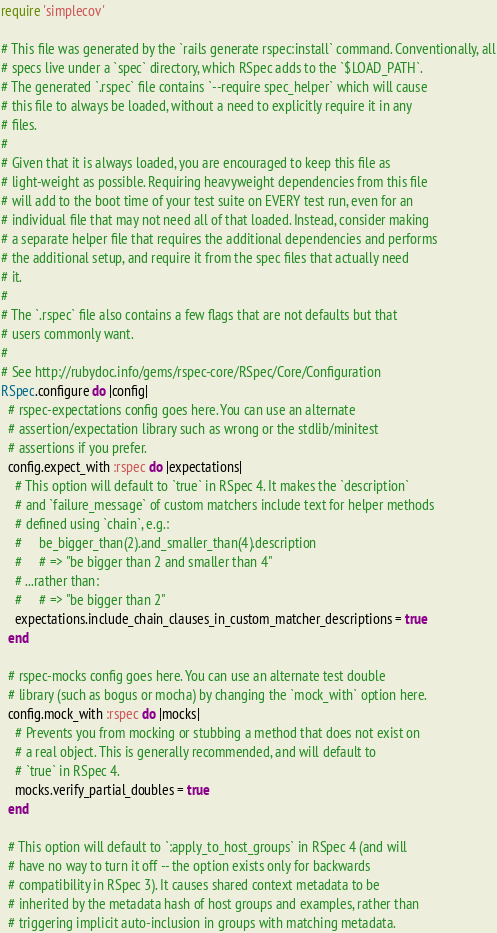<code> <loc_0><loc_0><loc_500><loc_500><_Ruby_>require 'simplecov'

# This file was generated by the `rails generate rspec:install` command. Conventionally, all
# specs live under a `spec` directory, which RSpec adds to the `$LOAD_PATH`.
# The generated `.rspec` file contains `--require spec_helper` which will cause
# this file to always be loaded, without a need to explicitly require it in any
# files.
#
# Given that it is always loaded, you are encouraged to keep this file as
# light-weight as possible. Requiring heavyweight dependencies from this file
# will add to the boot time of your test suite on EVERY test run, even for an
# individual file that may not need all of that loaded. Instead, consider making
# a separate helper file that requires the additional dependencies and performs
# the additional setup, and require it from the spec files that actually need
# it.
#
# The `.rspec` file also contains a few flags that are not defaults but that
# users commonly want.
#
# See http://rubydoc.info/gems/rspec-core/RSpec/Core/Configuration
RSpec.configure do |config|
  # rspec-expectations config goes here. You can use an alternate
  # assertion/expectation library such as wrong or the stdlib/minitest
  # assertions if you prefer.
  config.expect_with :rspec do |expectations|
    # This option will default to `true` in RSpec 4. It makes the `description`
    # and `failure_message` of custom matchers include text for helper methods
    # defined using `chain`, e.g.:
    #     be_bigger_than(2).and_smaller_than(4).description
    #     # => "be bigger than 2 and smaller than 4"
    # ...rather than:
    #     # => "be bigger than 2"
    expectations.include_chain_clauses_in_custom_matcher_descriptions = true
  end

  # rspec-mocks config goes here. You can use an alternate test double
  # library (such as bogus or mocha) by changing the `mock_with` option here.
  config.mock_with :rspec do |mocks|
    # Prevents you from mocking or stubbing a method that does not exist on
    # a real object. This is generally recommended, and will default to
    # `true` in RSpec 4.
    mocks.verify_partial_doubles = true
  end

  # This option will default to `:apply_to_host_groups` in RSpec 4 (and will
  # have no way to turn it off -- the option exists only for backwards
  # compatibility in RSpec 3). It causes shared context metadata to be
  # inherited by the metadata hash of host groups and examples, rather than
  # triggering implicit auto-inclusion in groups with matching metadata.</code> 